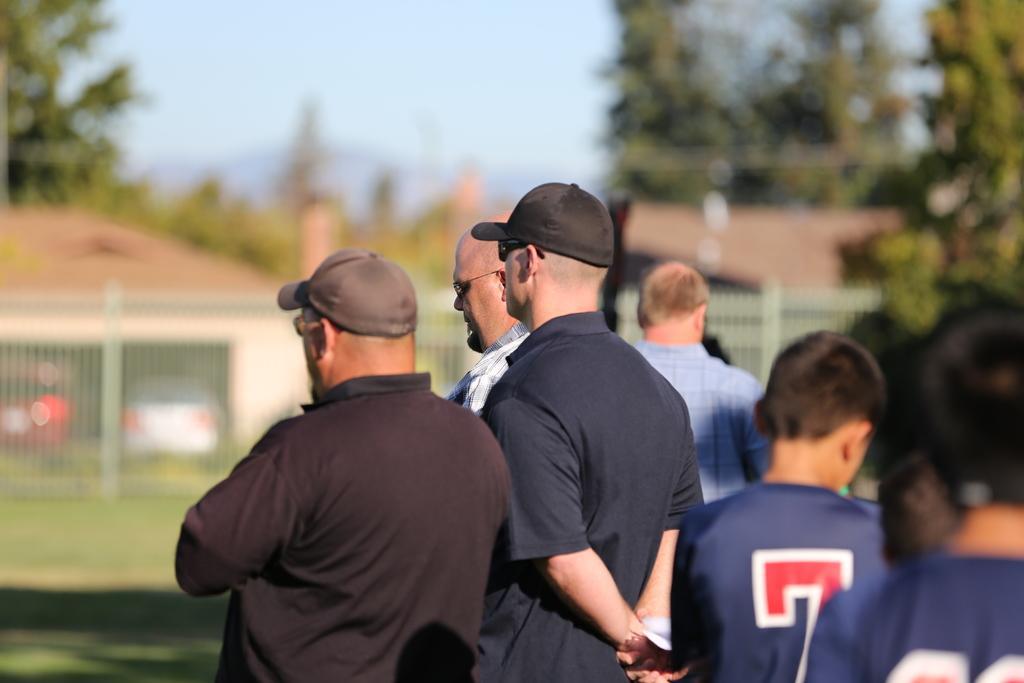Please provide a concise description of this image. In this image, we can see people standing and some of them are wearing caps. In the background, there is a fence, sheds and we can see some trees. 